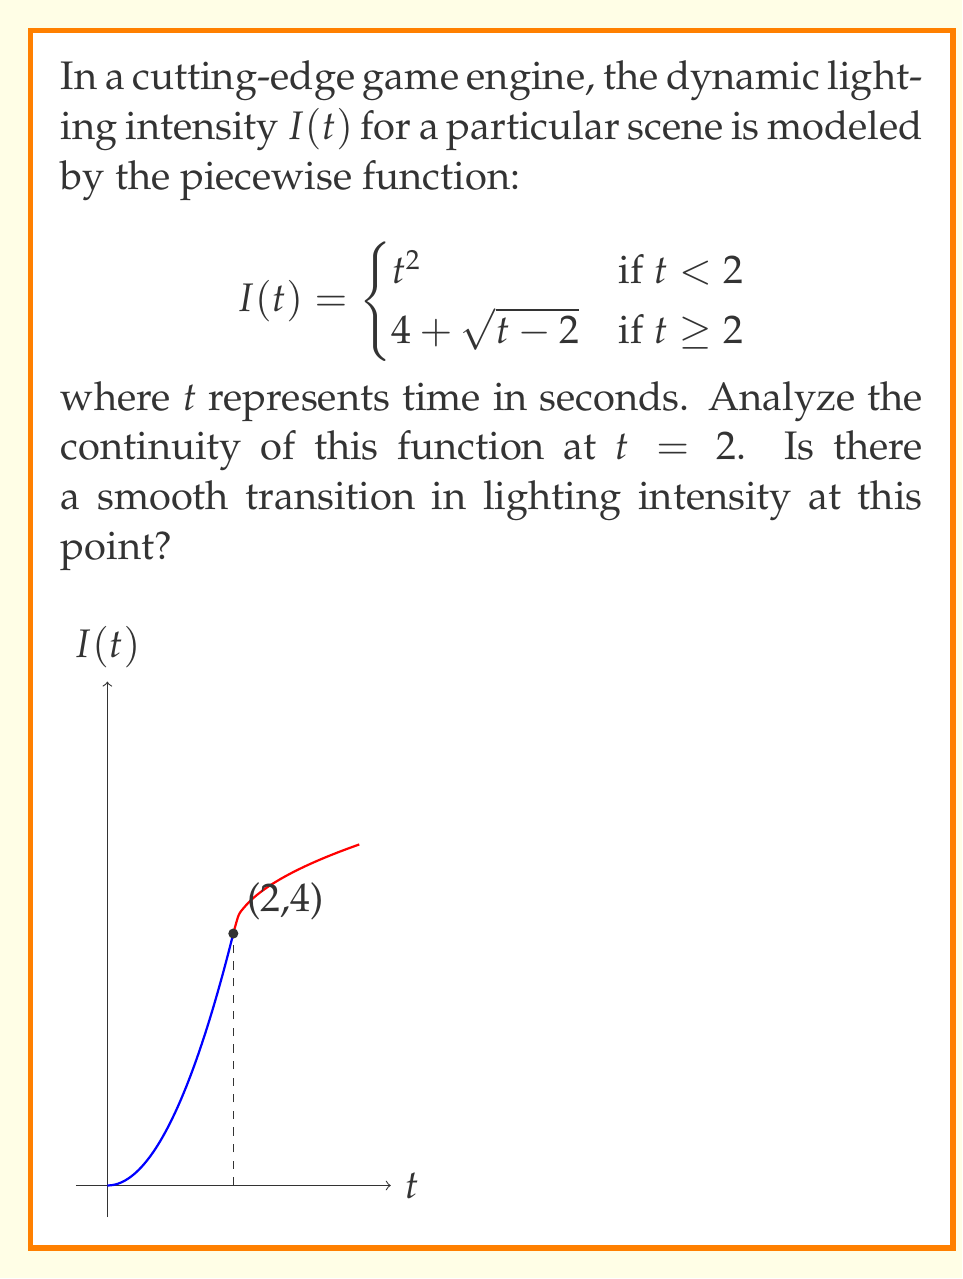Can you answer this question? To analyze the continuity of $I(t)$ at $t = 2$, we need to check if the following three conditions are met:

1. $I(t)$ is defined at $t = 2$
2. $\lim_{t \to 2^-} I(t)$ exists
3. $\lim_{t \to 2^+} I(t)$ exists
4. $\lim_{t \to 2^-} I(t) = \lim_{t \to 2^+} I(t) = I(2)$

Let's check each condition:

1. $I(2)$ is defined:
   For $t \geq 2$, $I(2) = 4 + \sqrt{2-2} = 4 + 0 = 4$

2. $\lim_{t \to 2^-} I(t)$:
   $$\lim_{t \to 2^-} I(t) = \lim_{t \to 2^-} t^2 = 2^2 = 4$$

3. $\lim_{t \to 2^+} I(t)$:
   $$\lim_{t \to 2^+} I(t) = \lim_{t \to 2^+} (4 + \sqrt{t-2}) = 4 + \sqrt{0} = 4$$

4. Comparing the results:
   $\lim_{t \to 2^-} I(t) = \lim_{t \to 2^+} I(t) = I(2) = 4$

Since all conditions are met, $I(t)$ is continuous at $t = 2$. This means there is a smooth transition in lighting intensity at this point, which is crucial for maintaining immersive graphics without noticeable jumps in lighting.
Answer: $I(t)$ is continuous at $t = 2$. 